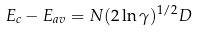<formula> <loc_0><loc_0><loc_500><loc_500>E _ { c } - E _ { a v } = N ( 2 \ln \gamma ) ^ { 1 / 2 } D</formula> 